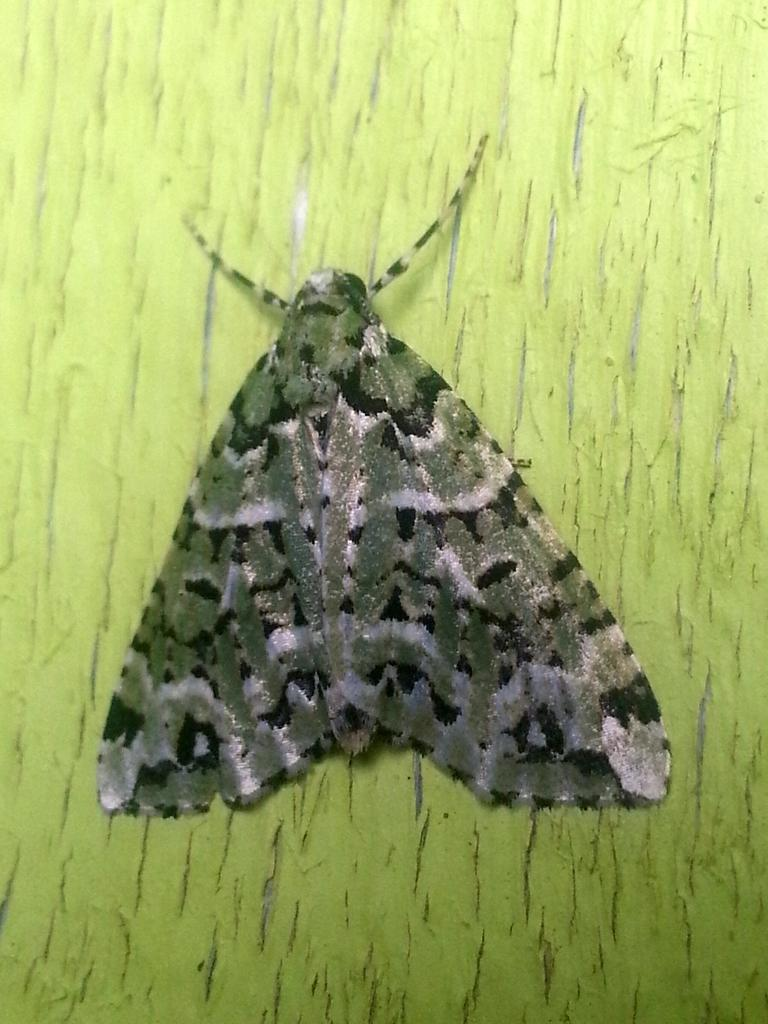What type of creature can be seen in the image? There is an insect in the image. What color is the background of the image? The background of the image is light green. What type of rice can be seen growing on the twig in the image? There is no rice or twig present in the image; it features an insect with a light green background. 